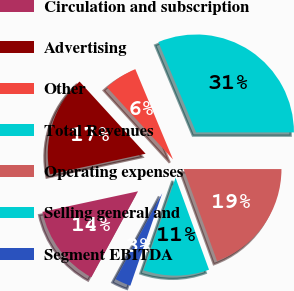Convert chart. <chart><loc_0><loc_0><loc_500><loc_500><pie_chart><fcel>Circulation and subscription<fcel>Advertising<fcel>Other<fcel>Total Revenues<fcel>Operating expenses<fcel>Selling general and<fcel>Segment EBITDA<nl><fcel>13.71%<fcel>16.58%<fcel>5.5%<fcel>31.3%<fcel>19.44%<fcel>10.84%<fcel>2.63%<nl></chart> 